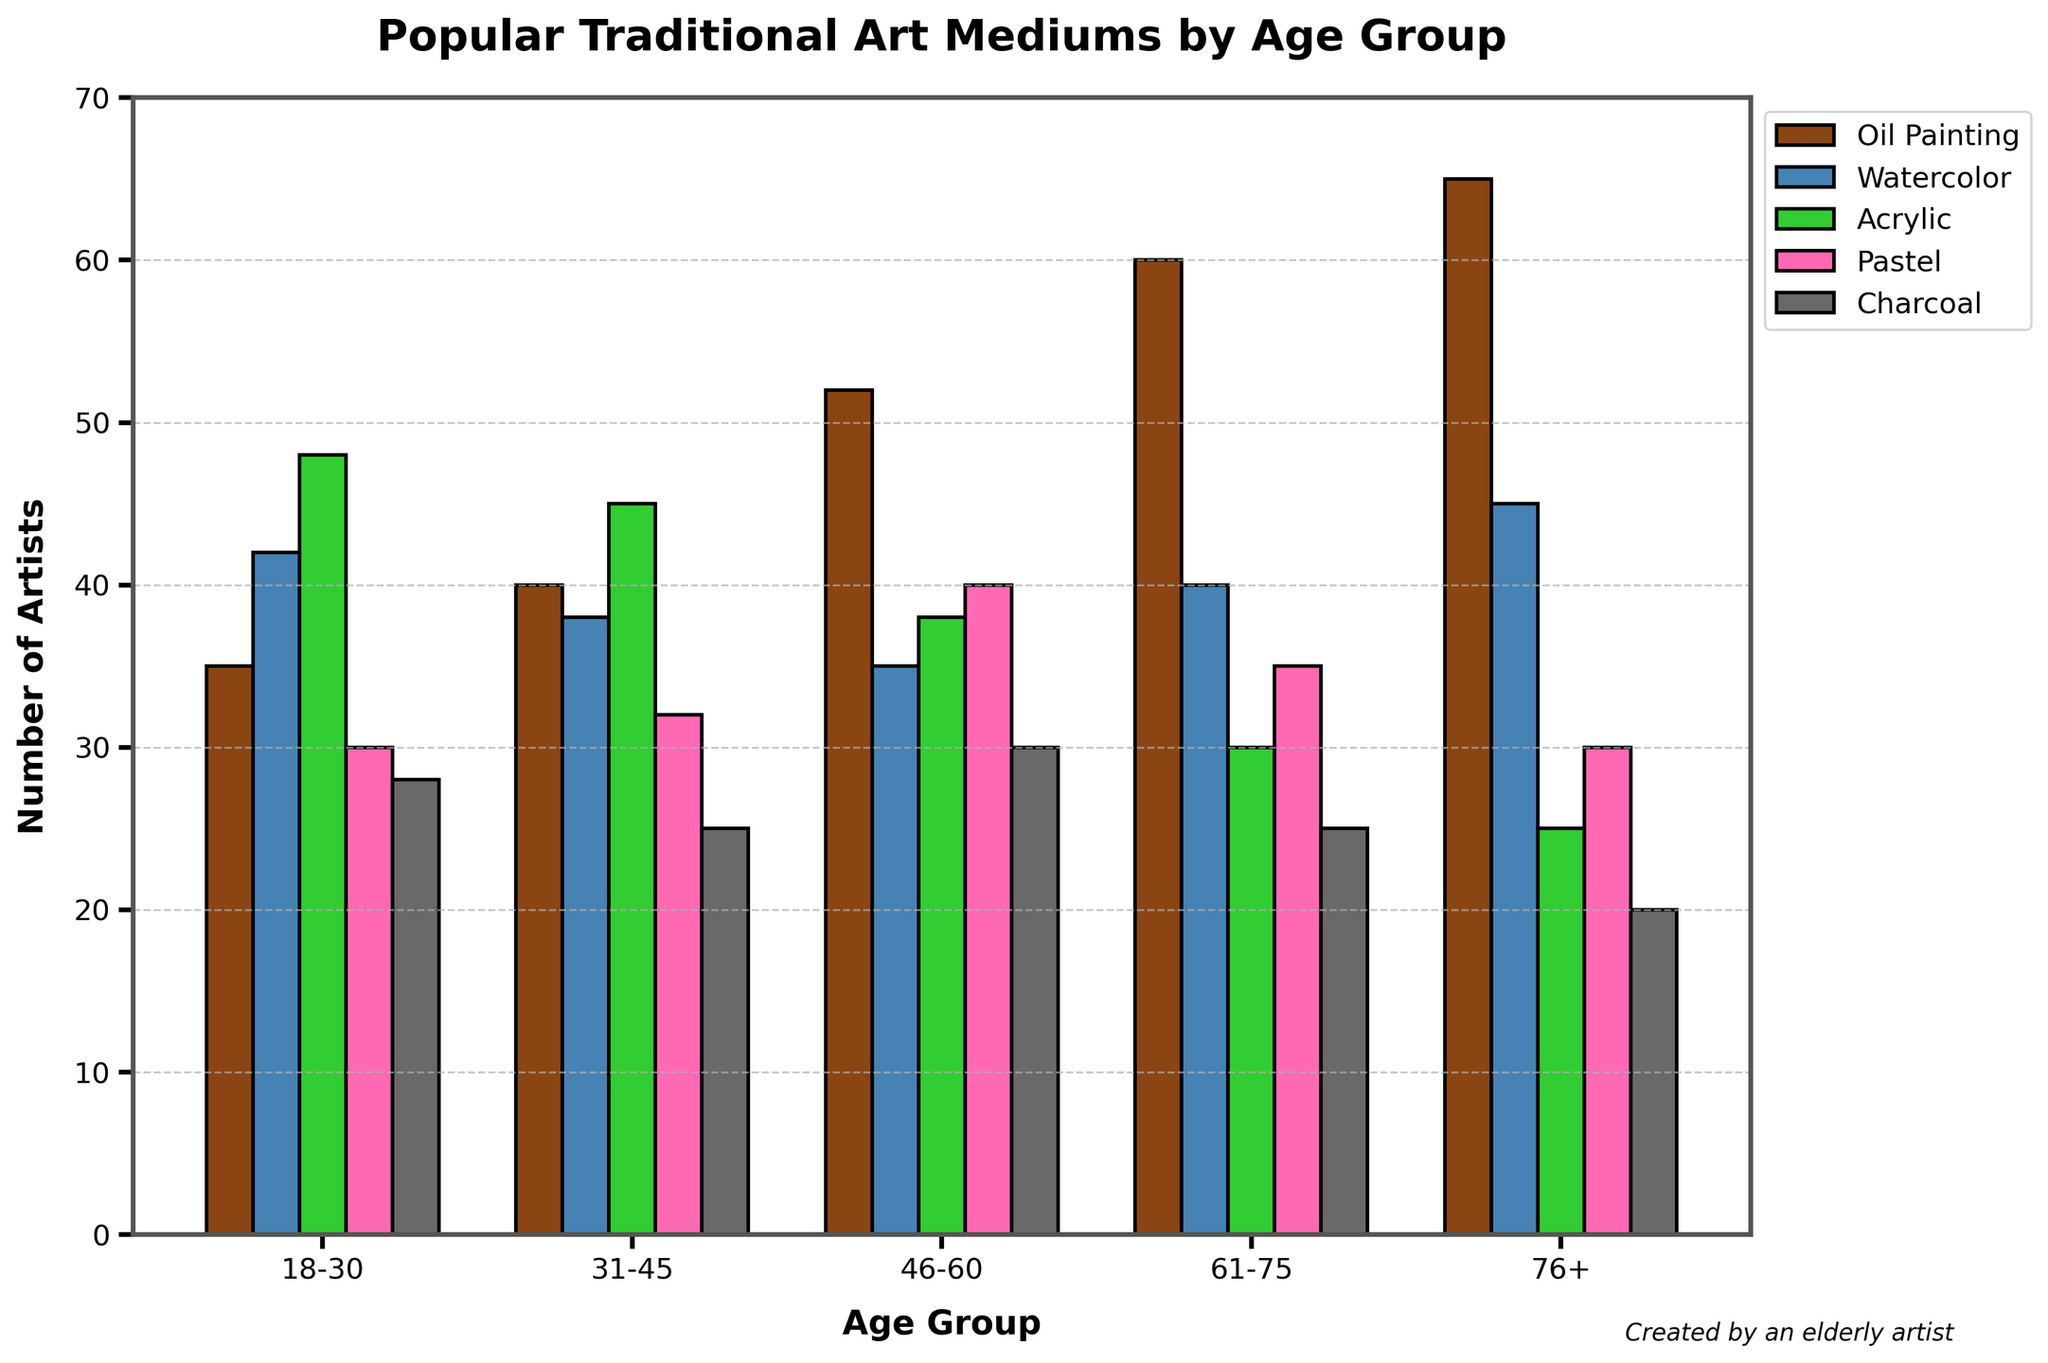Which age group has the highest number of artists using oil painting? By examining the heights of the bars corresponding to oil painting for each age group, we can see that the age group 76+ has the highest bar. Hence, the age group 76+ has the most artists using oil painting.
Answer: 76+ Which medium is the most popular among artists aged 31-45? For the age group 31-45, the tallest bar represents oil painting. Thus, oil painting is the most popular medium among artists aged 31-45.
Answer: Oil Painting What is the total number of artists using pastel across all age groups? Summing up the number of artists using pastel from all age groups: 30 (18-30) + 32 (31-45) + 40 (46-60) + 35 (61-75) + 30 (76+), we get 167 artists in total.
Answer: 167 Is the number of artists using watercolor higher among the 18-30 age group compared to the 61-75 age group? The data shows that the number of artists using watercolor in the 18-30 age group is 42, whereas it is 40 in the 61-75 age group. Comparing these values, 42 is greater than 40.
Answer: Yes How does the popularity of acrylic painting compare between the 18-30 and 46-60 age groups? To compare, we look at the heights of the acrylic painting bars for the two age groups. The 18-30 age group has 48 artists, while the 46-60 age group has 38 artists. Thus, acrylic painting is more popular among the 18-30 age group than the 46-60 age group.
Answer: 18-30 What is the difference in the number of charcoal artists between the youngest and oldest age groups? The number of charcoal artists in the 18-30 age group is 28, whereas in the 76+ age group, it is 20. The difference is calculated as 28 - 20 = 8.
Answer: 8 Which medium has the least number of artists in the 46-60 age group? For the 46-60 age group, the shortest bar represents the medium with the least number of artists, which is acrylic with 38 artists.
Answer: Acrylic What is the average number of artists using charcoal across all age groups? Summing up the number of artists using charcoal: 28 (18-30) + 25 (31-45) + 30 (46-60) + 25 (61-75) + 20 (76+), we get a total of 128. Dividing by the 5 age groups: 128 / 5 = 25.6.
Answer: 25.6 Which two mediums are equally popular in the 31-45 age group? For the age group 31-45, the bars for pastel and charcoal are equal in height, both with 25 artists each.
Answer: Pastel and Charcoal In which age group is watercolor not the most popular medium? By examining the heights of the bars for watercolor across all age groups, we see that watercolor is not the most popular medium in the 46-60, 61-75, and 76+ age groups.
Answer: 46-60, 61-75, and 76+ 